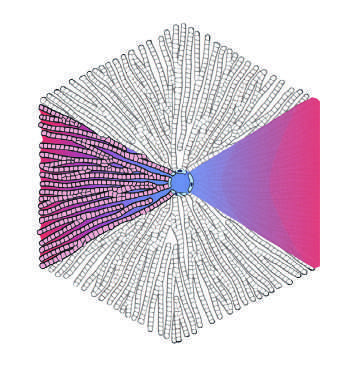where are the portal tracts?
Answer the question using a single word or phrase. At the periphery 